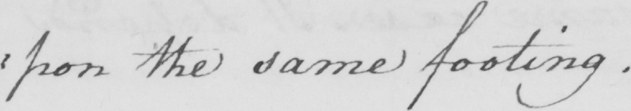What is written in this line of handwriting? :pon the same footing. 